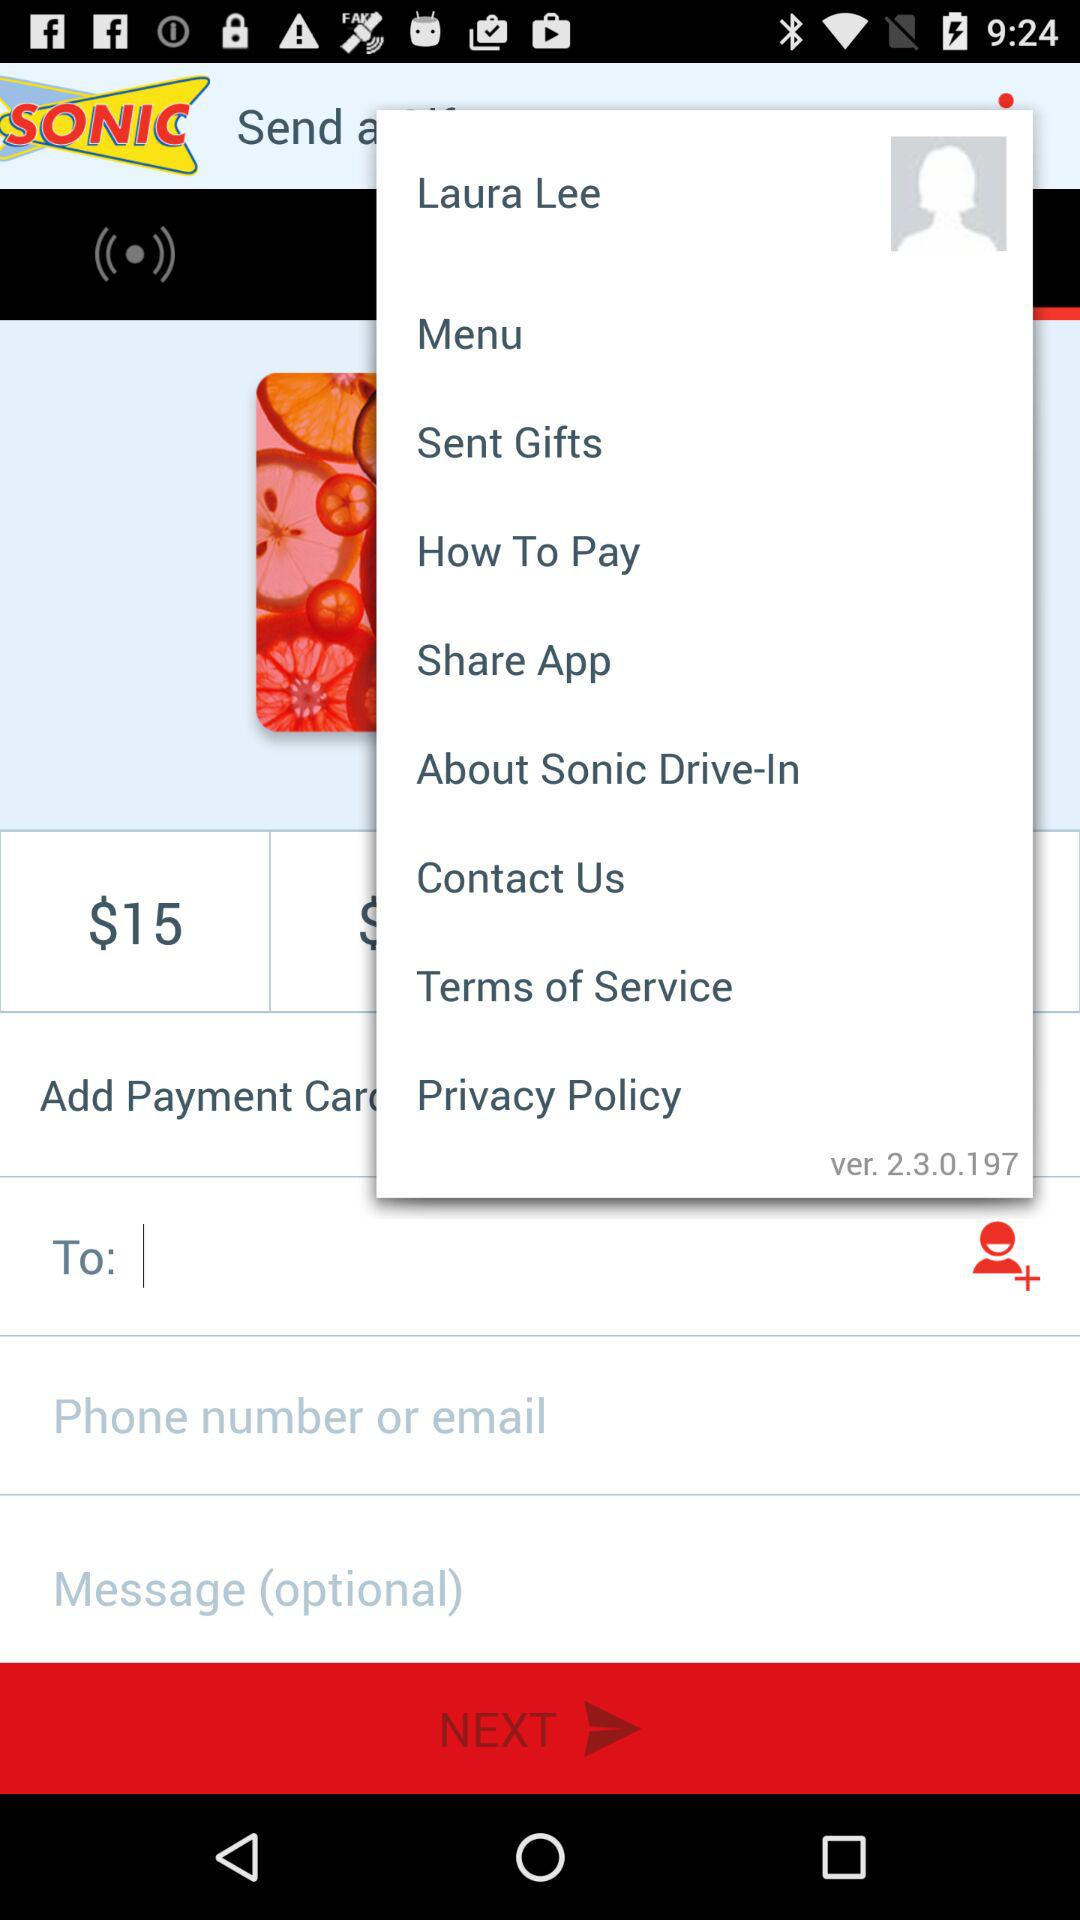What is the amount mentioned here? The mentioned amount is $15. 